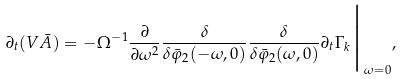<formula> <loc_0><loc_0><loc_500><loc_500>\partial _ { t } ( V \bar { A } ) = - \Omega ^ { - 1 } \frac { \partial } { \partial \omega ^ { 2 } } \frac { \delta } { \delta \bar { \varphi } _ { 2 } ( - \omega , 0 ) } \frac { \delta } { \delta \bar { \varphi } _ { 2 } ( \omega , 0 ) } \partial _ { t } \Gamma _ { k } \Big { | } _ { \omega = 0 } ,</formula> 